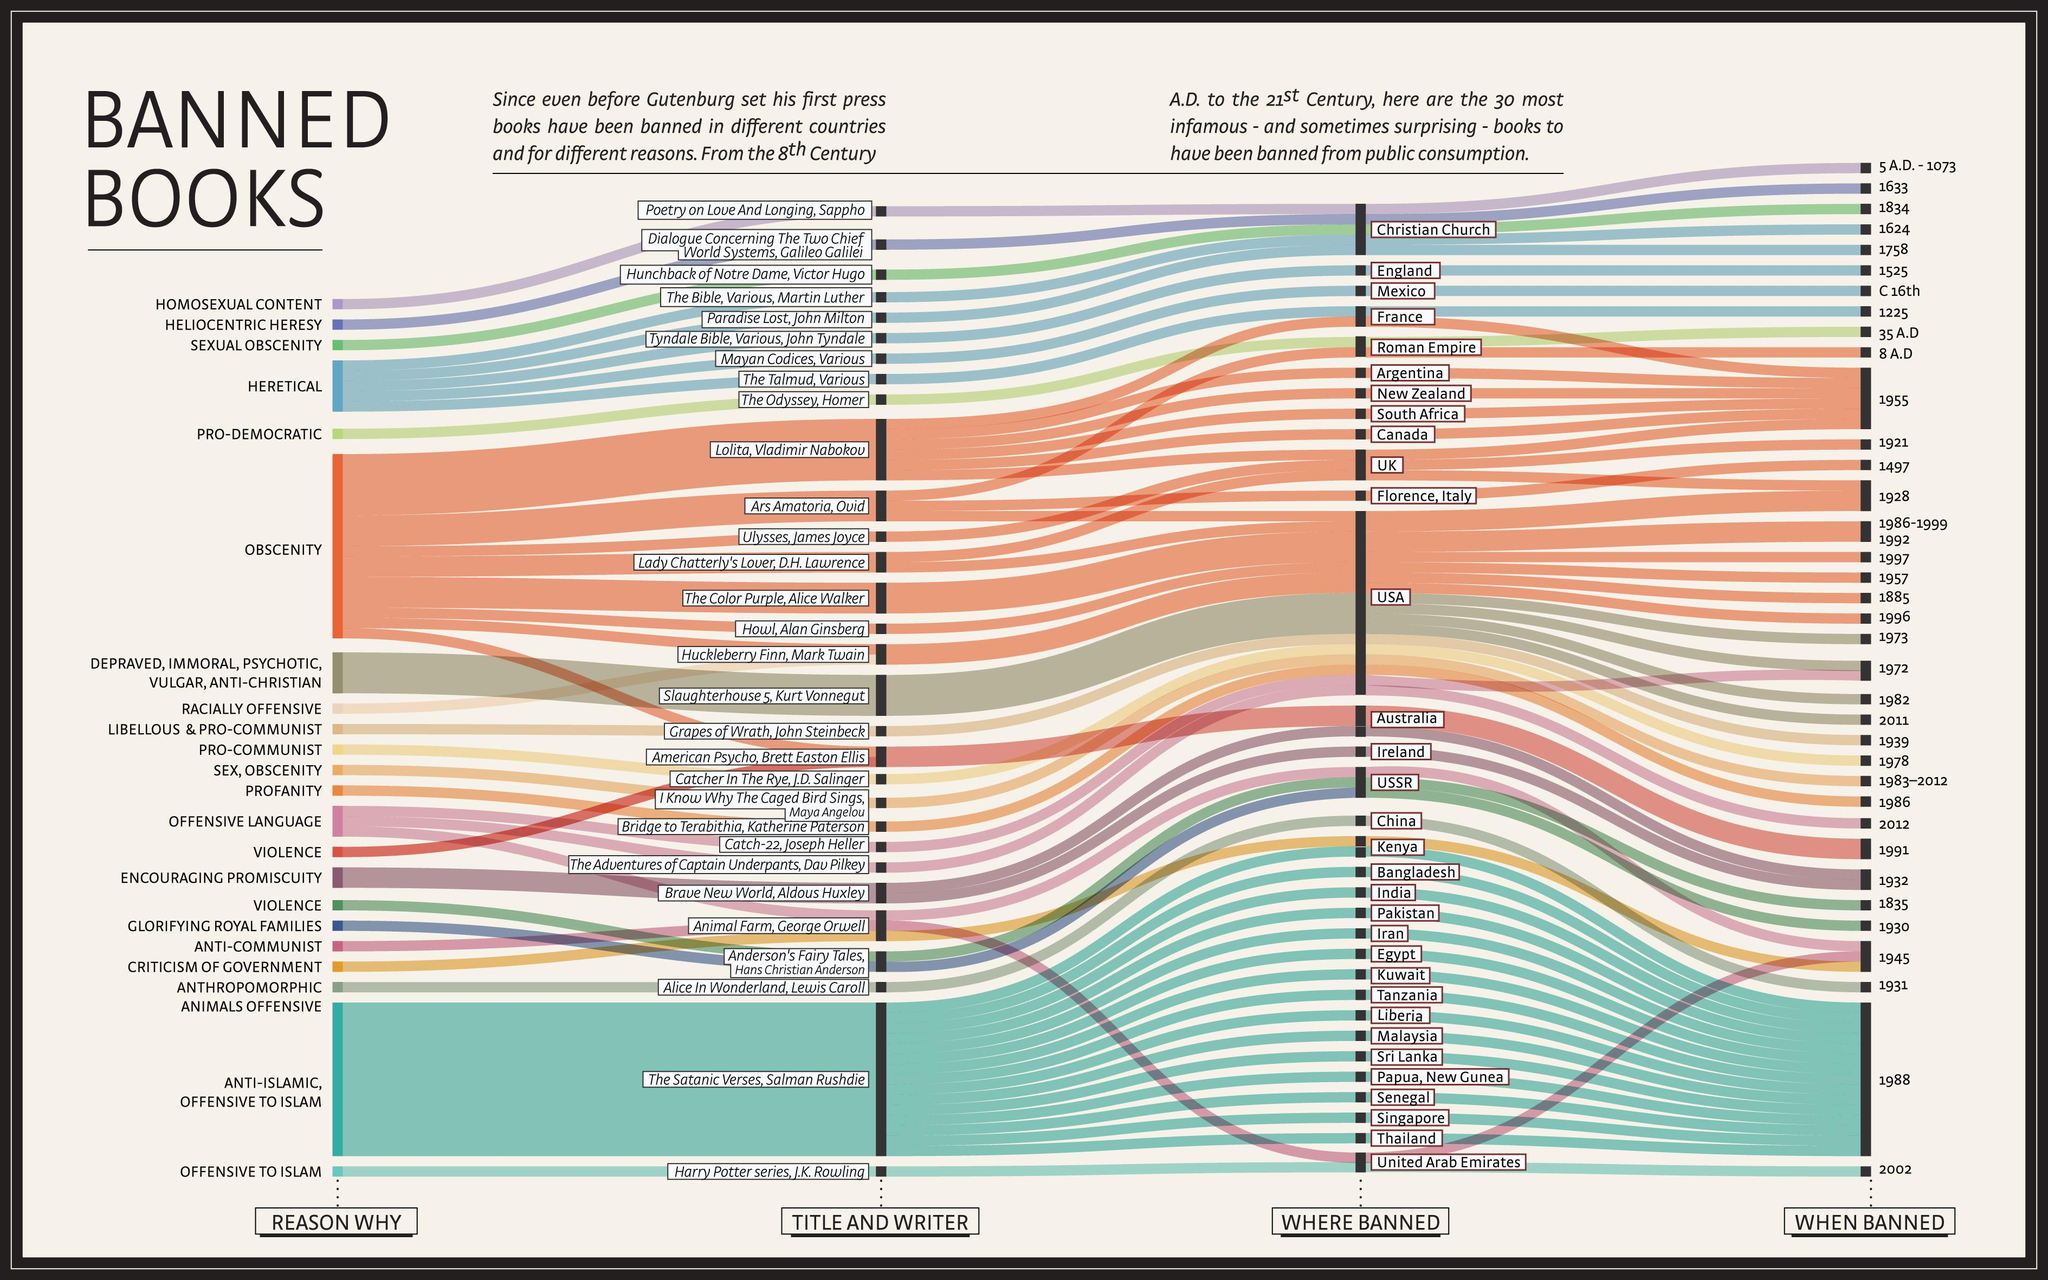List a handful of essential elements in this visual. Two books have been banned due to their violent nature. 